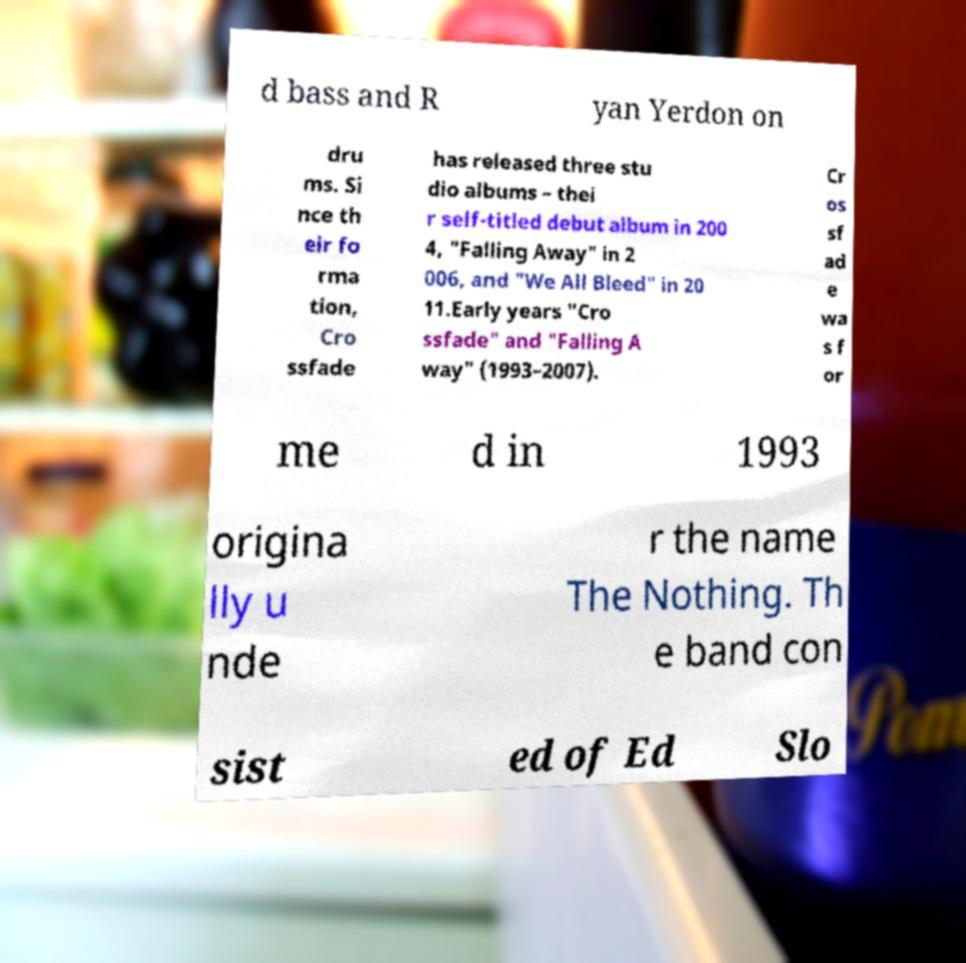I need the written content from this picture converted into text. Can you do that? d bass and R yan Yerdon on dru ms. Si nce th eir fo rma tion, Cro ssfade has released three stu dio albums – thei r self-titled debut album in 200 4, "Falling Away" in 2 006, and "We All Bleed" in 20 11.Early years "Cro ssfade" and "Falling A way" (1993–2007). Cr os sf ad e wa s f or me d in 1993 origina lly u nde r the name The Nothing. Th e band con sist ed of Ed Slo 